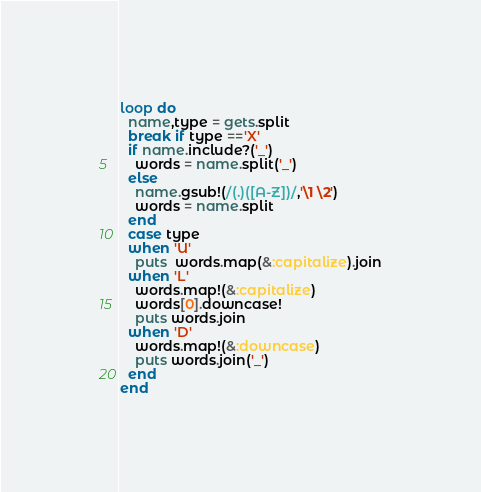<code> <loc_0><loc_0><loc_500><loc_500><_Ruby_>loop do
  name,type = gets.split
  break if type =='X'
  if name.include?('_')
    words = name.split('_')
  else
    name.gsub!(/(.)([A-Z])/,'\1 \2')
    words = name.split
  end
  case type
  when 'U'
    puts  words.map(&:capitalize).join
  when 'L'
    words.map!(&:capitalize)
    words[0].downcase!
    puts words.join
  when 'D'
    words.map!(&:downcase)
    puts words.join('_')
  end
end</code> 